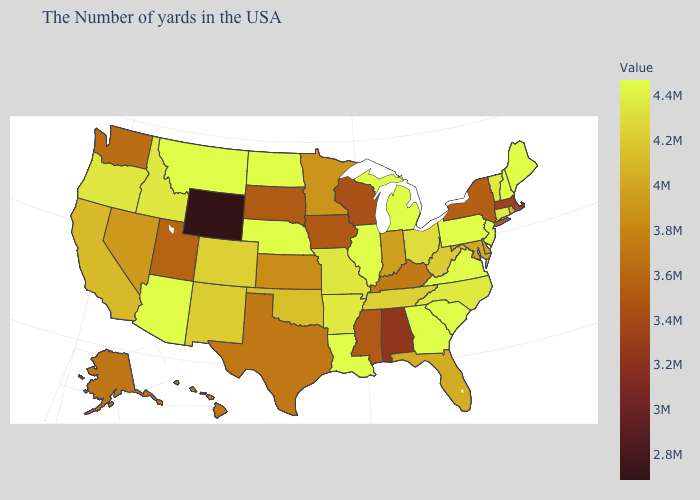Among the states that border Washington , does Oregon have the highest value?
Concise answer only. No. Among the states that border Minnesota , which have the highest value?
Answer briefly. North Dakota. Which states hav the highest value in the MidWest?
Keep it brief. Michigan, Illinois, Nebraska, North Dakota. Which states have the highest value in the USA?
Short answer required. Maine, New Hampshire, New Jersey, Pennsylvania, Virginia, South Carolina, Georgia, Michigan, Illinois, Louisiana, Nebraska, North Dakota, Montana, Arizona. Does Arizona have the highest value in the USA?
Short answer required. Yes. Does Minnesota have the lowest value in the USA?
Quick response, please. No. Does Virginia have the lowest value in the USA?
Short answer required. No. 